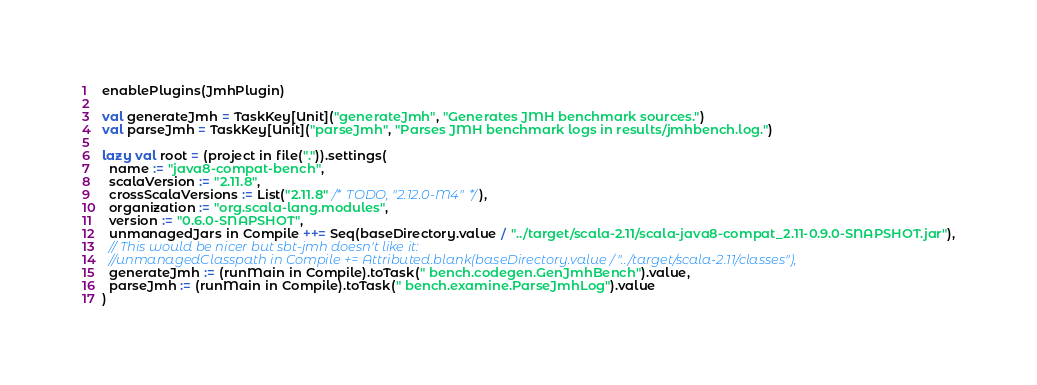<code> <loc_0><loc_0><loc_500><loc_500><_Scala_>enablePlugins(JmhPlugin)

val generateJmh = TaskKey[Unit]("generateJmh", "Generates JMH benchmark sources.")
val parseJmh = TaskKey[Unit]("parseJmh", "Parses JMH benchmark logs in results/jmhbench.log.")

lazy val root = (project in file(".")).settings(
  name := "java8-compat-bench",
  scalaVersion := "2.11.8",
  crossScalaVersions := List("2.11.8" /* TODO, "2.12.0-M4"*/),
  organization := "org.scala-lang.modules",
  version := "0.6.0-SNAPSHOT",
  unmanagedJars in Compile ++= Seq(baseDirectory.value / "../target/scala-2.11/scala-java8-compat_2.11-0.9.0-SNAPSHOT.jar"),
  // This would be nicer but sbt-jmh doesn't like it:
  //unmanagedClasspath in Compile += Attributed.blank(baseDirectory.value / "../target/scala-2.11/classes"),
  generateJmh := (runMain in Compile).toTask(" bench.codegen.GenJmhBench").value,
  parseJmh := (runMain in Compile).toTask(" bench.examine.ParseJmhLog").value
)
</code> 